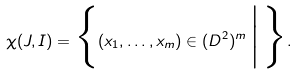<formula> <loc_0><loc_0><loc_500><loc_500>\chi ( J , I ) = \Big \{ ( x _ { 1 } , \dots , x _ { m } ) \in ( D ^ { 2 } ) ^ { m } \, \Big | \, \Big \} .</formula> 